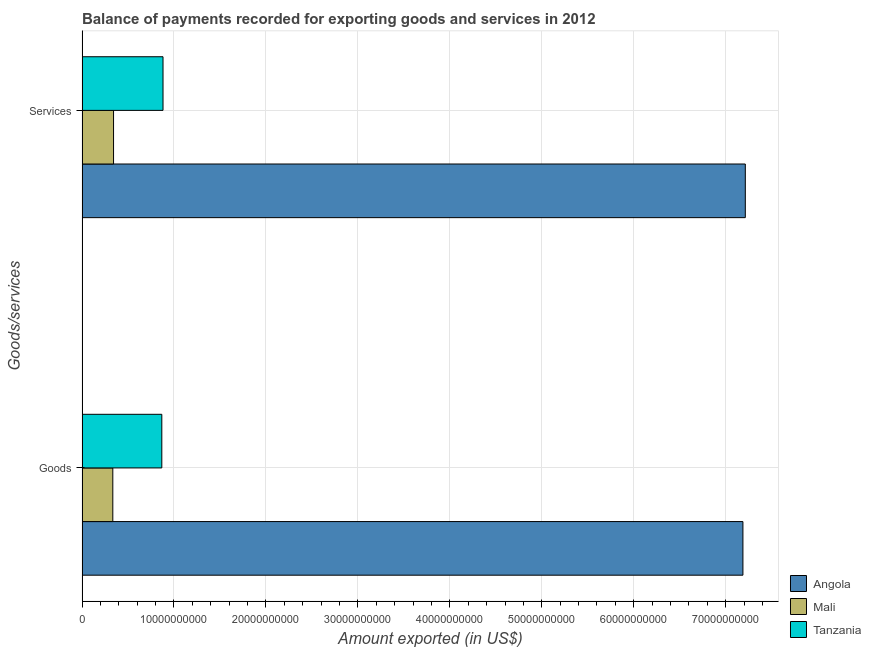Are the number of bars per tick equal to the number of legend labels?
Your answer should be very brief. Yes. Are the number of bars on each tick of the Y-axis equal?
Make the answer very short. Yes. What is the label of the 1st group of bars from the top?
Provide a short and direct response. Services. What is the amount of goods exported in Angola?
Make the answer very short. 7.19e+1. Across all countries, what is the maximum amount of services exported?
Provide a succinct answer. 7.21e+1. Across all countries, what is the minimum amount of services exported?
Give a very brief answer. 3.43e+09. In which country was the amount of goods exported maximum?
Give a very brief answer. Angola. In which country was the amount of goods exported minimum?
Give a very brief answer. Mali. What is the total amount of services exported in the graph?
Your answer should be very brief. 8.44e+1. What is the difference between the amount of services exported in Mali and that in Tanzania?
Give a very brief answer. -5.38e+09. What is the difference between the amount of goods exported in Mali and the amount of services exported in Tanzania?
Ensure brevity in your answer.  -5.46e+09. What is the average amount of goods exported per country?
Ensure brevity in your answer.  2.80e+1. What is the difference between the amount of services exported and amount of goods exported in Tanzania?
Give a very brief answer. 1.31e+08. In how many countries, is the amount of services exported greater than 46000000000 US$?
Make the answer very short. 1. What is the ratio of the amount of goods exported in Tanzania to that in Angola?
Ensure brevity in your answer.  0.12. In how many countries, is the amount of services exported greater than the average amount of services exported taken over all countries?
Make the answer very short. 1. What does the 3rd bar from the top in Goods represents?
Provide a succinct answer. Angola. What does the 1st bar from the bottom in Goods represents?
Your answer should be compact. Angola. Are all the bars in the graph horizontal?
Keep it short and to the point. Yes. How many countries are there in the graph?
Provide a succinct answer. 3. Are the values on the major ticks of X-axis written in scientific E-notation?
Provide a succinct answer. No. Does the graph contain grids?
Your answer should be compact. Yes. How many legend labels are there?
Provide a succinct answer. 3. What is the title of the graph?
Offer a very short reply. Balance of payments recorded for exporting goods and services in 2012. What is the label or title of the X-axis?
Keep it short and to the point. Amount exported (in US$). What is the label or title of the Y-axis?
Keep it short and to the point. Goods/services. What is the Amount exported (in US$) in Angola in Goods?
Make the answer very short. 7.19e+1. What is the Amount exported (in US$) of Mali in Goods?
Provide a short and direct response. 3.35e+09. What is the Amount exported (in US$) in Tanzania in Goods?
Make the answer very short. 8.68e+09. What is the Amount exported (in US$) in Angola in Services?
Your response must be concise. 7.21e+1. What is the Amount exported (in US$) of Mali in Services?
Give a very brief answer. 3.43e+09. What is the Amount exported (in US$) in Tanzania in Services?
Your answer should be compact. 8.81e+09. Across all Goods/services, what is the maximum Amount exported (in US$) of Angola?
Your response must be concise. 7.21e+1. Across all Goods/services, what is the maximum Amount exported (in US$) of Mali?
Your answer should be very brief. 3.43e+09. Across all Goods/services, what is the maximum Amount exported (in US$) in Tanzania?
Provide a succinct answer. 8.81e+09. Across all Goods/services, what is the minimum Amount exported (in US$) in Angola?
Offer a terse response. 7.19e+1. Across all Goods/services, what is the minimum Amount exported (in US$) of Mali?
Make the answer very short. 3.35e+09. Across all Goods/services, what is the minimum Amount exported (in US$) of Tanzania?
Provide a succinct answer. 8.68e+09. What is the total Amount exported (in US$) of Angola in the graph?
Your answer should be very brief. 1.44e+11. What is the total Amount exported (in US$) of Mali in the graph?
Make the answer very short. 6.77e+09. What is the total Amount exported (in US$) of Tanzania in the graph?
Make the answer very short. 1.75e+1. What is the difference between the Amount exported (in US$) of Angola in Goods and that in Services?
Ensure brevity in your answer.  -2.60e+08. What is the difference between the Amount exported (in US$) of Mali in Goods and that in Services?
Your answer should be very brief. -8.11e+07. What is the difference between the Amount exported (in US$) of Tanzania in Goods and that in Services?
Keep it short and to the point. -1.31e+08. What is the difference between the Amount exported (in US$) in Angola in Goods and the Amount exported (in US$) in Mali in Services?
Offer a very short reply. 6.84e+1. What is the difference between the Amount exported (in US$) in Angola in Goods and the Amount exported (in US$) in Tanzania in Services?
Provide a short and direct response. 6.31e+1. What is the difference between the Amount exported (in US$) in Mali in Goods and the Amount exported (in US$) in Tanzania in Services?
Make the answer very short. -5.46e+09. What is the average Amount exported (in US$) of Angola per Goods/services?
Keep it short and to the point. 7.20e+1. What is the average Amount exported (in US$) of Mali per Goods/services?
Make the answer very short. 3.39e+09. What is the average Amount exported (in US$) of Tanzania per Goods/services?
Your answer should be compact. 8.74e+09. What is the difference between the Amount exported (in US$) in Angola and Amount exported (in US$) in Mali in Goods?
Provide a succinct answer. 6.85e+1. What is the difference between the Amount exported (in US$) in Angola and Amount exported (in US$) in Tanzania in Goods?
Offer a very short reply. 6.32e+1. What is the difference between the Amount exported (in US$) in Mali and Amount exported (in US$) in Tanzania in Goods?
Provide a succinct answer. -5.33e+09. What is the difference between the Amount exported (in US$) of Angola and Amount exported (in US$) of Mali in Services?
Your response must be concise. 6.87e+1. What is the difference between the Amount exported (in US$) of Angola and Amount exported (in US$) of Tanzania in Services?
Your response must be concise. 6.33e+1. What is the difference between the Amount exported (in US$) of Mali and Amount exported (in US$) of Tanzania in Services?
Offer a terse response. -5.38e+09. What is the ratio of the Amount exported (in US$) of Mali in Goods to that in Services?
Give a very brief answer. 0.98. What is the ratio of the Amount exported (in US$) of Tanzania in Goods to that in Services?
Your answer should be compact. 0.99. What is the difference between the highest and the second highest Amount exported (in US$) in Angola?
Your answer should be compact. 2.60e+08. What is the difference between the highest and the second highest Amount exported (in US$) in Mali?
Keep it short and to the point. 8.11e+07. What is the difference between the highest and the second highest Amount exported (in US$) in Tanzania?
Offer a terse response. 1.31e+08. What is the difference between the highest and the lowest Amount exported (in US$) of Angola?
Offer a very short reply. 2.60e+08. What is the difference between the highest and the lowest Amount exported (in US$) of Mali?
Keep it short and to the point. 8.11e+07. What is the difference between the highest and the lowest Amount exported (in US$) of Tanzania?
Your response must be concise. 1.31e+08. 